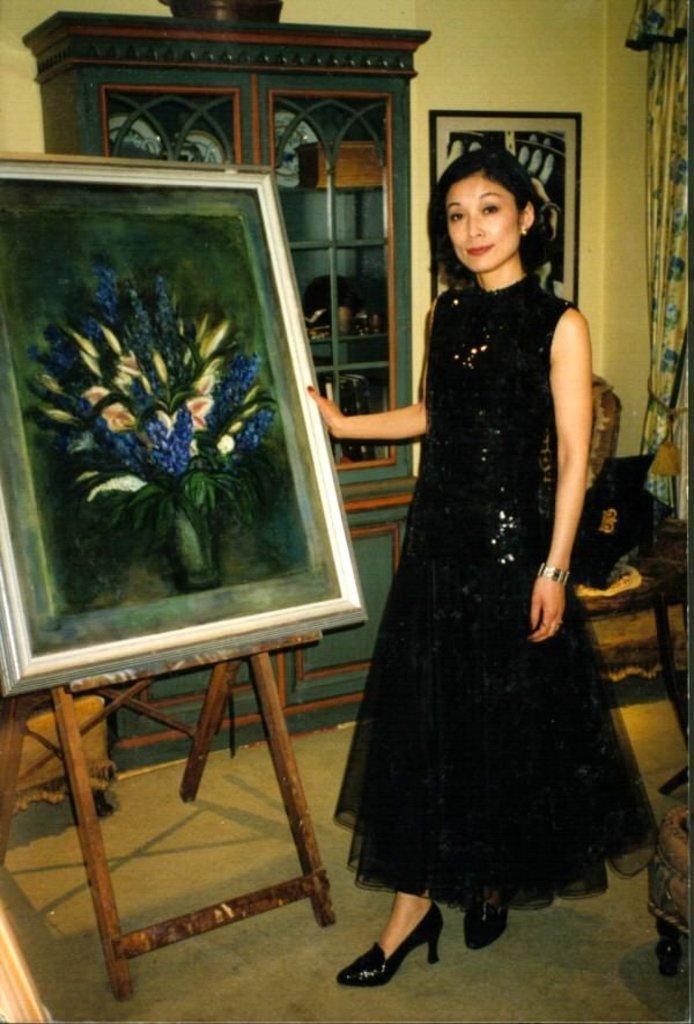Describe this image in one or two sentences. In this image I can see the person with the black color dress. In-front of the person I can see the board with painting. It is on the wooden stand. In the background I can see the cupboard, board and the curtain to the wall. 